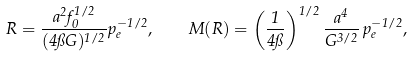<formula> <loc_0><loc_0><loc_500><loc_500>R = \frac { a ^ { 2 } f _ { 0 } ^ { 1 / 2 } } { ( 4 \pi G ) ^ { 1 / 2 } } p _ { e } ^ { - 1 / 2 } , \quad M ( R ) = \left ( \frac { 1 } { 4 \pi } \right ) ^ { 1 / 2 } \frac { a ^ { 4 } } { G ^ { 3 / 2 } } \, p _ { e } ^ { - 1 / 2 } ,</formula> 